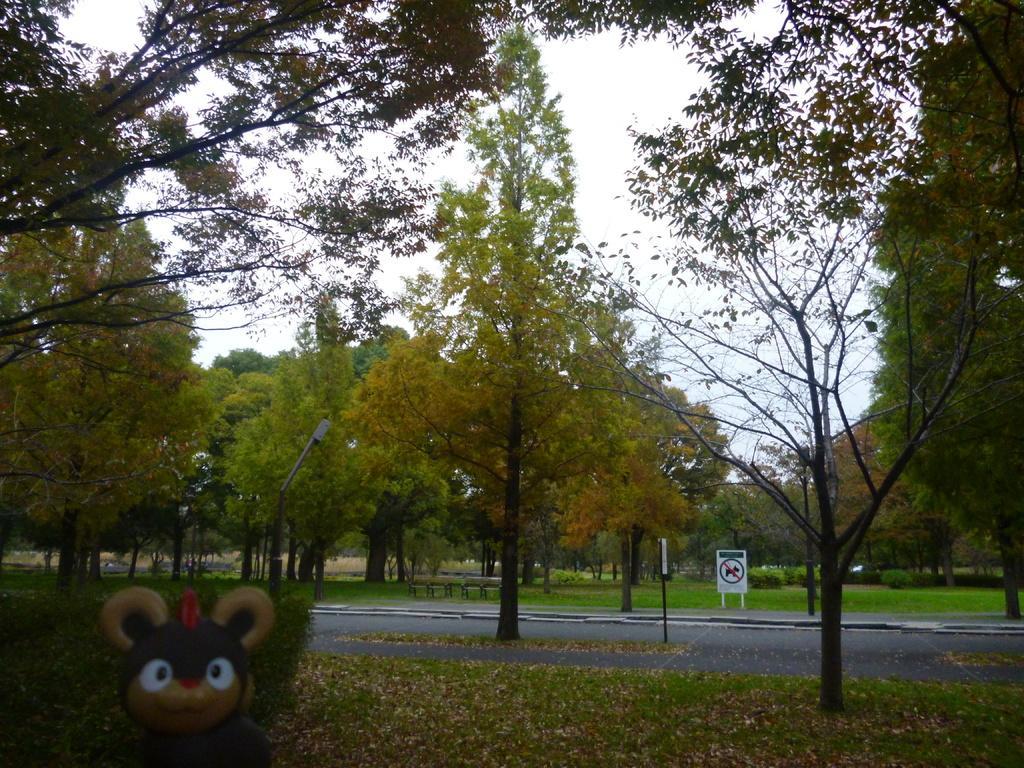Can you describe this image briefly? In this picture we can see some trees, grass and sign boards are placed on the road, some dry leaves on the surface and we can see the toy. 